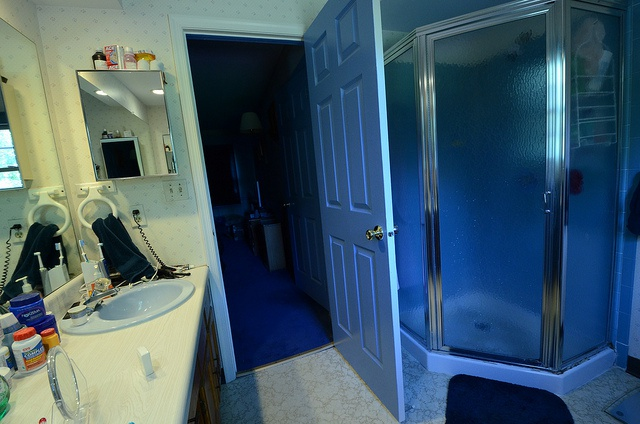Describe the objects in this image and their specific colors. I can see sink in darkgray, gray, and lightgray tones, bottle in darkgray, olive, maroon, and orange tones, bottle in darkgray, gray, and beige tones, hair drier in darkgray, black, darkgreen, and gray tones, and tv in darkgray, black, navy, blue, and darkblue tones in this image. 